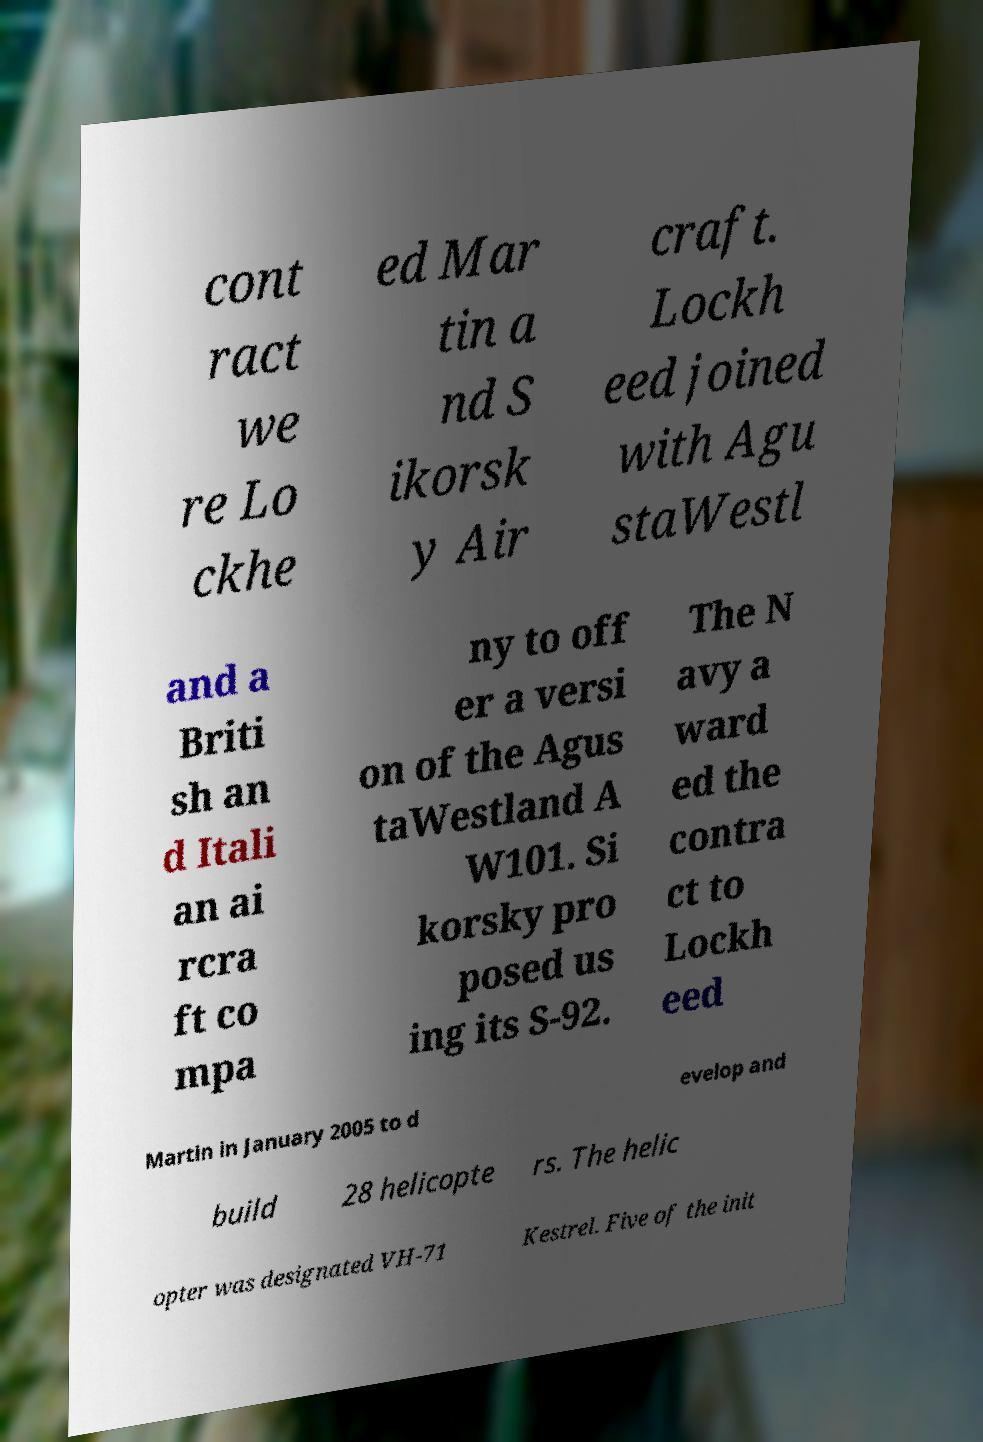Can you accurately transcribe the text from the provided image for me? cont ract we re Lo ckhe ed Mar tin a nd S ikorsk y Air craft. Lockh eed joined with Agu staWestl and a Briti sh an d Itali an ai rcra ft co mpa ny to off er a versi on of the Agus taWestland A W101. Si korsky pro posed us ing its S-92. The N avy a ward ed the contra ct to Lockh eed Martin in January 2005 to d evelop and build 28 helicopte rs. The helic opter was designated VH-71 Kestrel. Five of the init 